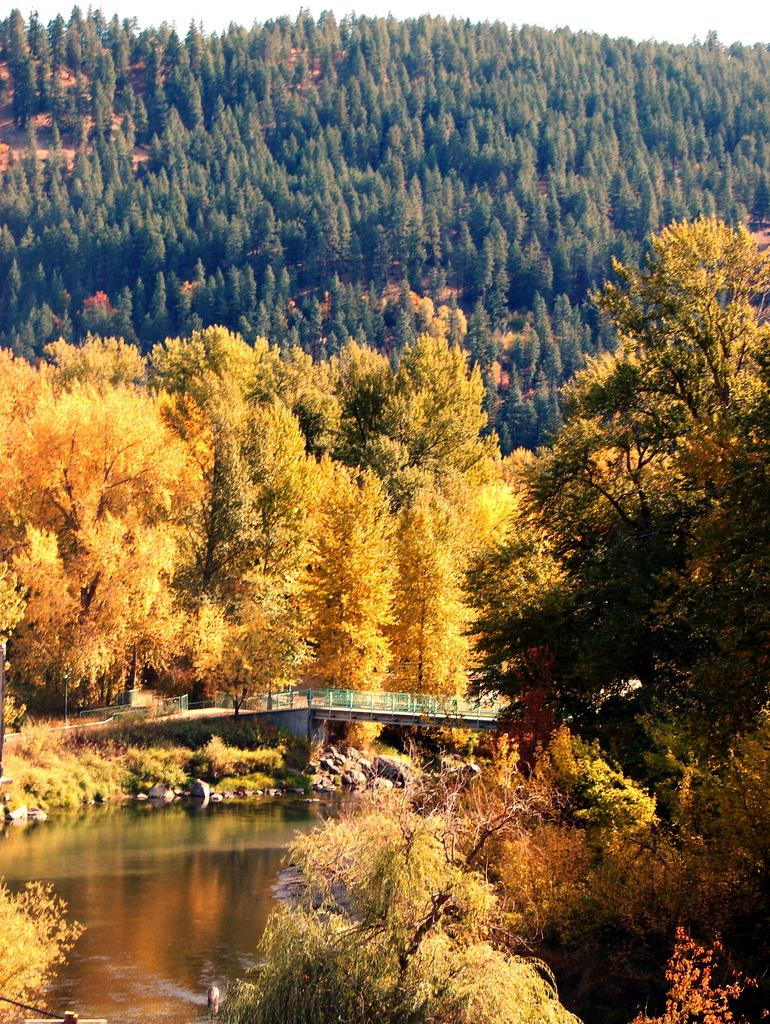What is the primary element present in the image? There is water in the image. What structure can be seen crossing over the water? There is a bridge in the image. What type of vegetation is visible in the image? There are trees in the image. What can be seen in the distance behind the water and trees? The sky is visible in the background of the image. What type of work is being done under the shade of the trees in the image? There is no indication of work or shade in the image; it primarily features water, a bridge, trees, and the sky. 